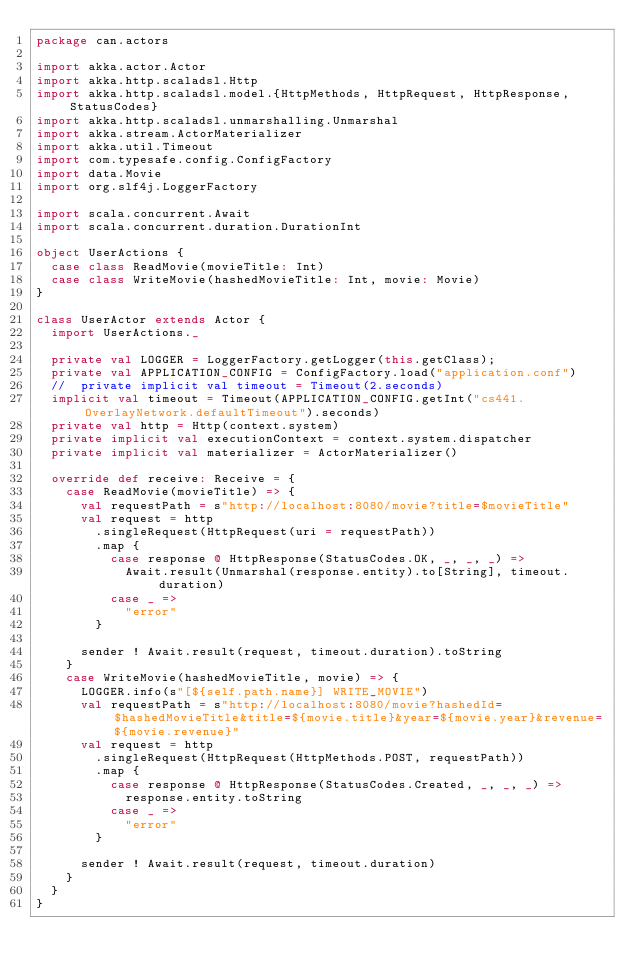Convert code to text. <code><loc_0><loc_0><loc_500><loc_500><_Scala_>package can.actors

import akka.actor.Actor
import akka.http.scaladsl.Http
import akka.http.scaladsl.model.{HttpMethods, HttpRequest, HttpResponse, StatusCodes}
import akka.http.scaladsl.unmarshalling.Unmarshal
import akka.stream.ActorMaterializer
import akka.util.Timeout
import com.typesafe.config.ConfigFactory
import data.Movie
import org.slf4j.LoggerFactory

import scala.concurrent.Await
import scala.concurrent.duration.DurationInt

object UserActions {
  case class ReadMovie(movieTitle: Int)
  case class WriteMovie(hashedMovieTitle: Int, movie: Movie)
}

class UserActor extends Actor {
  import UserActions._

  private val LOGGER = LoggerFactory.getLogger(this.getClass);
  private val APPLICATION_CONFIG = ConfigFactory.load("application.conf")
  //  private implicit val timeout = Timeout(2.seconds)
  implicit val timeout = Timeout(APPLICATION_CONFIG.getInt("cs441.OverlayNetwork.defaultTimeout").seconds)
  private val http = Http(context.system)
  private implicit val executionContext = context.system.dispatcher
  private implicit val materializer = ActorMaterializer()

  override def receive: Receive = {
    case ReadMovie(movieTitle) => {
      val requestPath = s"http://localhost:8080/movie?title=$movieTitle"
      val request = http
        .singleRequest(HttpRequest(uri = requestPath))
        .map {
          case response @ HttpResponse(StatusCodes.OK, _, _, _) =>
            Await.result(Unmarshal(response.entity).to[String], timeout.duration)
          case _ =>
            "error"
        }

      sender ! Await.result(request, timeout.duration).toString
    }
    case WriteMovie(hashedMovieTitle, movie) => {
      LOGGER.info(s"[${self.path.name}] WRITE_MOVIE")
      val requestPath = s"http://localhost:8080/movie?hashedId=$hashedMovieTitle&title=${movie.title}&year=${movie.year}&revenue=${movie.revenue}"
      val request = http
        .singleRequest(HttpRequest(HttpMethods.POST, requestPath))
        .map {
          case response @ HttpResponse(StatusCodes.Created, _, _, _) =>
            response.entity.toString
          case _ =>
            "error"
        }

      sender ! Await.result(request, timeout.duration)
    }
  }
}
</code> 